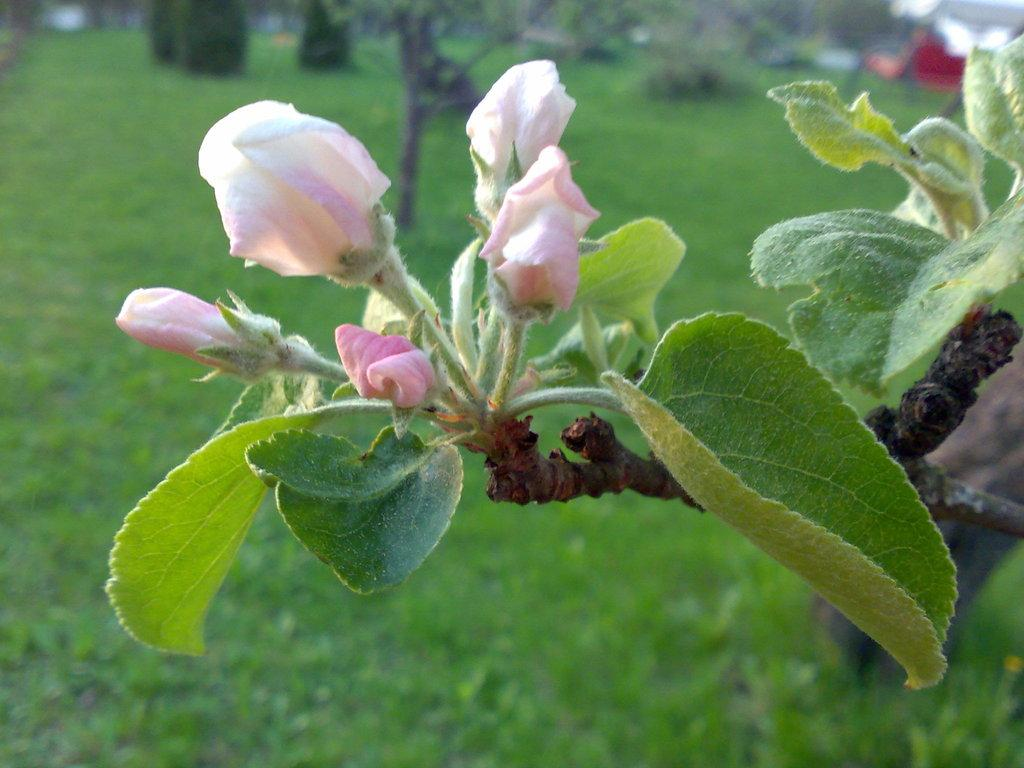What type of vegetation is present in the image? There are flowers, trees, and grass in the image. Can you describe the natural environment depicted in the image? The image features a natural environment with flowers, trees, and grass. What is visible in the background of the image? There are objects in the background of the image, although they are blurry. What type of holiday is being celebrated in the image? There is no indication of a holiday being celebrated in the image. What is being served for breakfast in the image? There is no breakfast or food visible in the image. 